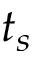<formula> <loc_0><loc_0><loc_500><loc_500>t _ { s }</formula> 